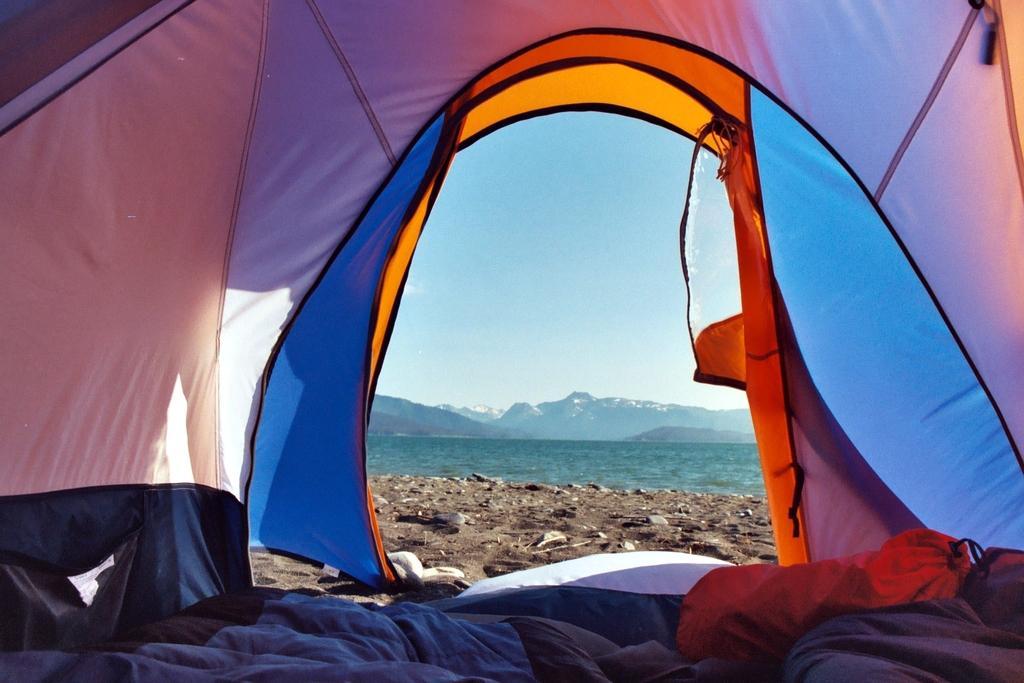Could you give a brief overview of what you see in this image? In this image I can see the tent in multicolor. In the background I can see the water, mountains and the sky is in blue color. 